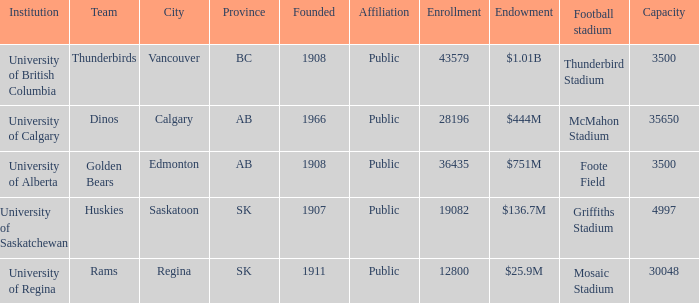How many institutions are shown for the football stadium of mosaic stadium? 1.0. 